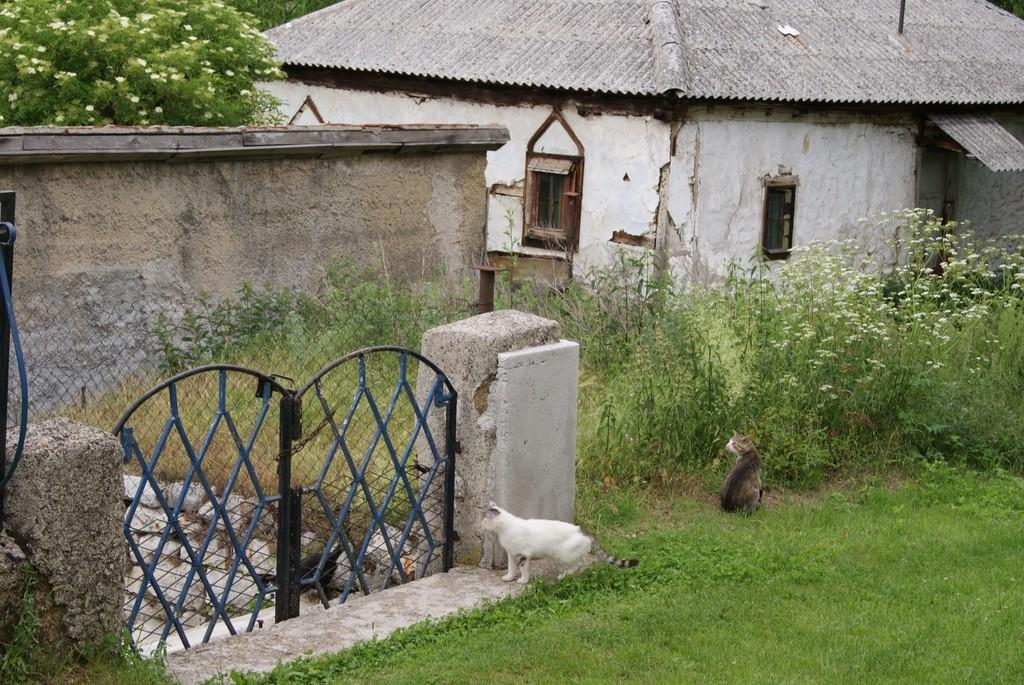How many cats are in the image? There are two cats in the image. Where are the cats located? The cats are on grassy land. What can be seen in the background of the image? There is a gate, planets, houses, and trees visible in the background of the image. What type of heart can be seen beating in the image? There is no heart visible in the image. Is there a hen present in the image? No, there is no hen present in the image. 